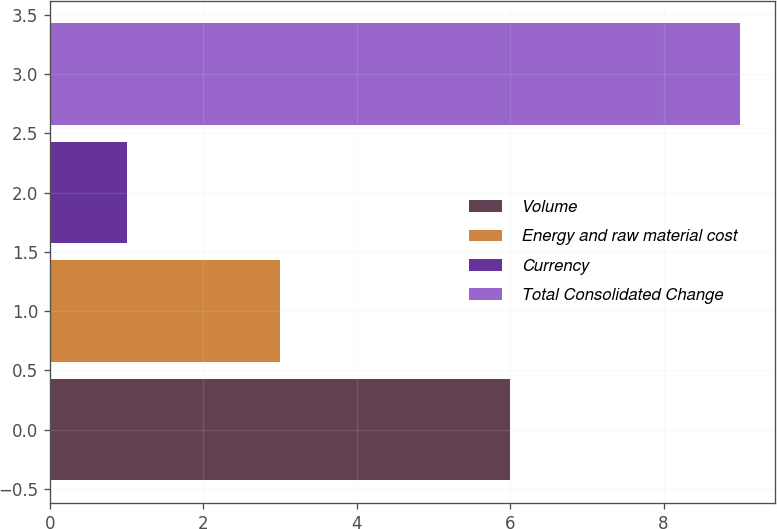<chart> <loc_0><loc_0><loc_500><loc_500><bar_chart><fcel>Volume<fcel>Energy and raw material cost<fcel>Currency<fcel>Total Consolidated Change<nl><fcel>6<fcel>3<fcel>1<fcel>9<nl></chart> 